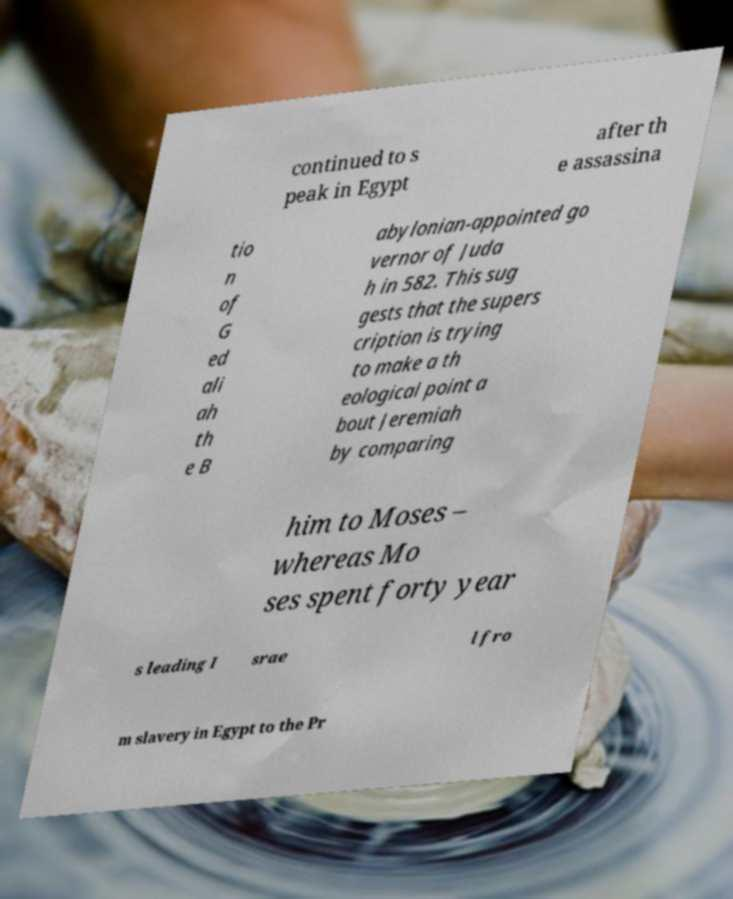For documentation purposes, I need the text within this image transcribed. Could you provide that? continued to s peak in Egypt after th e assassina tio n of G ed ali ah th e B abylonian-appointed go vernor of Juda h in 582. This sug gests that the supers cription is trying to make a th eological point a bout Jeremiah by comparing him to Moses – whereas Mo ses spent forty year s leading I srae l fro m slavery in Egypt to the Pr 